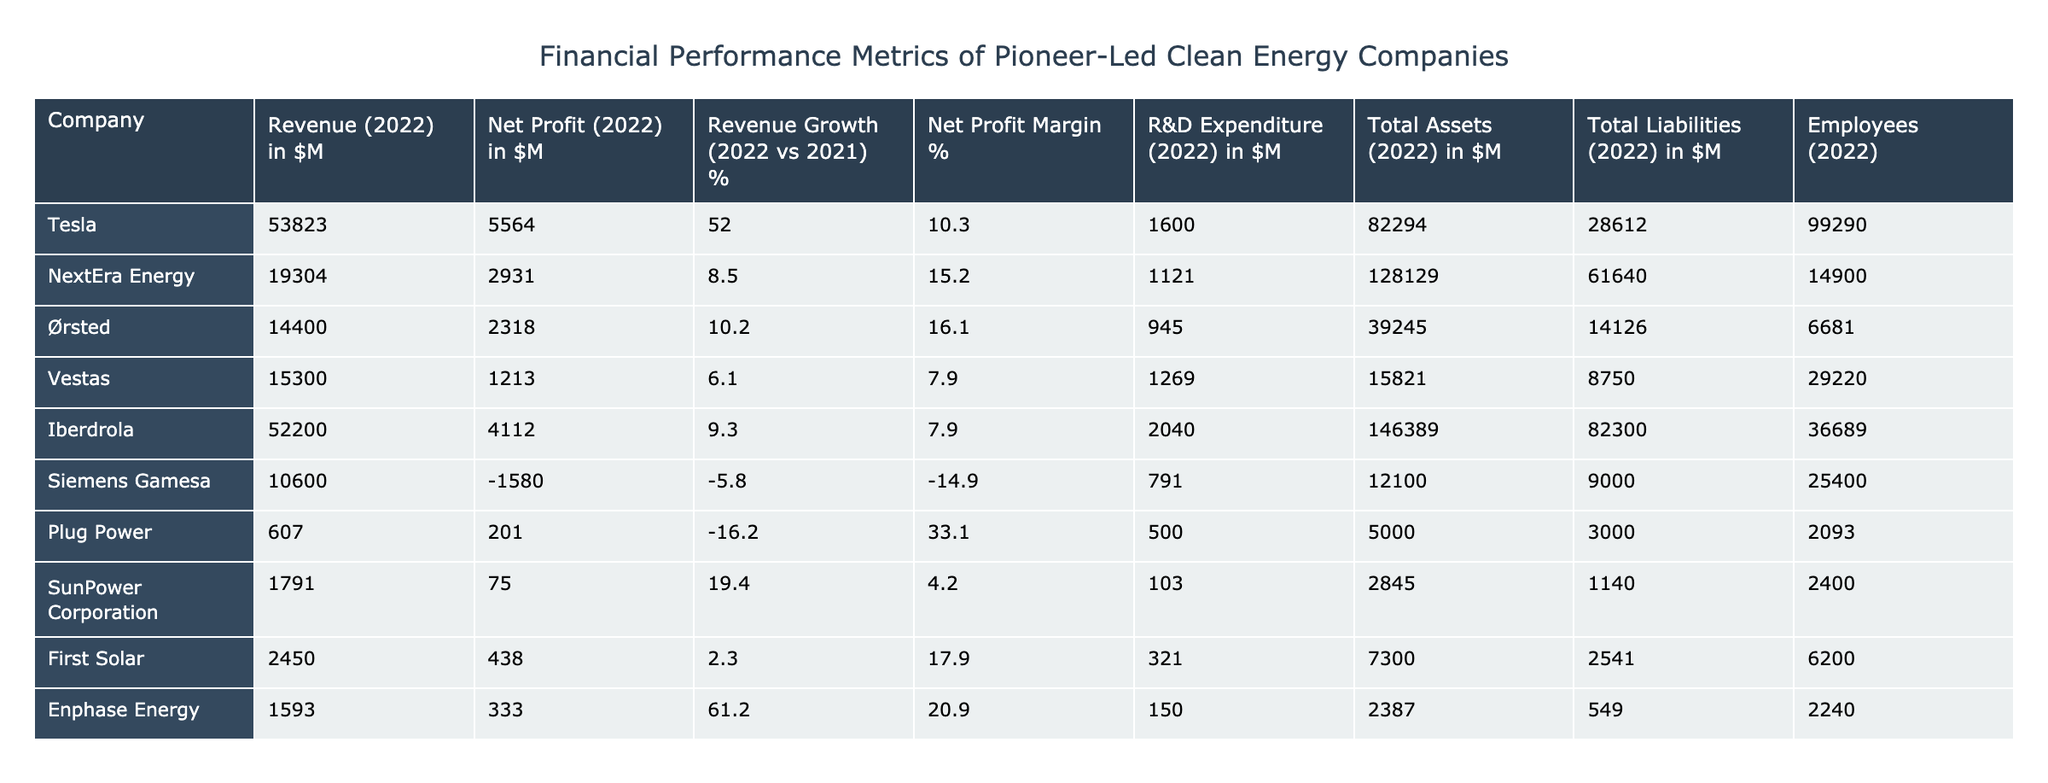What is Tesla's revenue for 2022 in millions? According to the table, the revenue for Tesla in 2022 is mentioned clearly. It is listed as 53,823 million dollars.
Answer: 53,823 million Which company reported a net profit margin of over 15% in 2022? By examining the net profit margin percentages in the table, both NextEra Energy and Ørsted have net profit margins greater than 15%. NextEra Energy has a margin of 15.2%, and Ørsted has a margin of 16.1%.
Answer: NextEra Energy and Ørsted What is the total liabilities of Iberdrola in millions? The table specifies the total liabilities for Iberdrola as 82,300 million dollars.
Answer: 82,300 million What is the average revenue growth of the companies listed in the table? The revenue growth percentages for the companies are: Tesla (52), NextEra Energy (8.5), Ørsted (10.2), Vestas (6.1), Iberdrola (9.3), Siemens Gamesa (-5.8), Plug Power (-16.2), SunPower Corporation (19.4), First Solar (2.3), and Enphase Energy (61.2). Adding these values gives a total of 142.1. There are 10 companies, so the average revenue growth is 142.1 divided by 10, which equals 14.21%.
Answer: 14.21% Is Siemens Gamesa's net profit in 2022 negative? The table shows that Siemens Gamesa reported a net profit of -1,580 million dollars, which is a negative value. Hence the statement is true.
Answer: Yes 